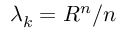<formula> <loc_0><loc_0><loc_500><loc_500>\lambda _ { k } = R ^ { n } / n</formula> 